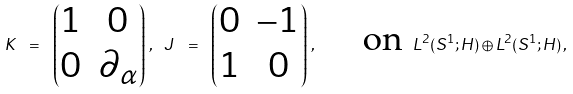Convert formula to latex. <formula><loc_0><loc_0><loc_500><loc_500>K \ = \ \begin{pmatrix} 1 & 0 \\ 0 & \partial _ { \alpha } \end{pmatrix} \, , \ J \ = \ \begin{pmatrix} 0 & - 1 \\ 1 & 0 \end{pmatrix} \, , \quad \text { on } L ^ { 2 } ( S ^ { 1 } ; H ) \oplus L ^ { 2 } ( S ^ { 1 } ; H ) \, ,</formula> 